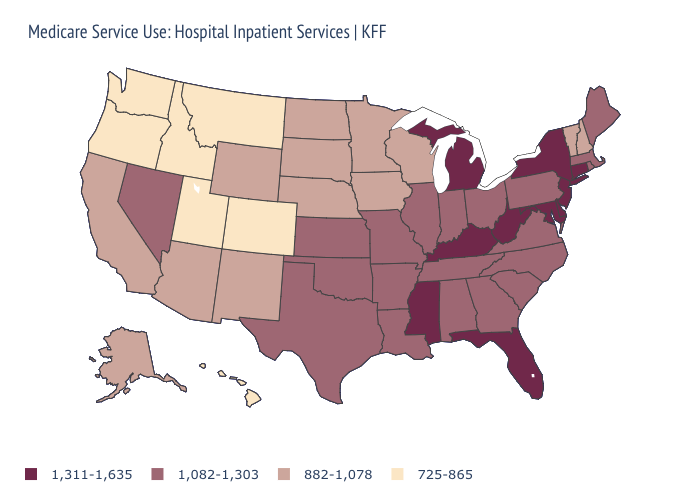Which states have the highest value in the USA?
Be succinct. Connecticut, Delaware, Florida, Kentucky, Maryland, Michigan, Mississippi, New Jersey, New York, West Virginia. Does the first symbol in the legend represent the smallest category?
Be succinct. No. Name the states that have a value in the range 725-865?
Short answer required. Colorado, Hawaii, Idaho, Montana, Oregon, Utah, Washington. Which states hav the highest value in the MidWest?
Concise answer only. Michigan. Does the first symbol in the legend represent the smallest category?
Quick response, please. No. What is the highest value in the MidWest ?
Answer briefly. 1,311-1,635. What is the highest value in the USA?
Write a very short answer. 1,311-1,635. What is the value of Mississippi?
Be succinct. 1,311-1,635. Does New Mexico have the same value as Florida?
Keep it brief. No. What is the highest value in the West ?
Answer briefly. 1,082-1,303. Name the states that have a value in the range 1,082-1,303?
Short answer required. Alabama, Arkansas, Georgia, Illinois, Indiana, Kansas, Louisiana, Maine, Massachusetts, Missouri, Nevada, North Carolina, Ohio, Oklahoma, Pennsylvania, Rhode Island, South Carolina, Tennessee, Texas, Virginia. Among the states that border Alabama , which have the highest value?
Be succinct. Florida, Mississippi. What is the value of Vermont?
Concise answer only. 882-1,078. What is the value of Nevada?
Quick response, please. 1,082-1,303. Is the legend a continuous bar?
Give a very brief answer. No. 